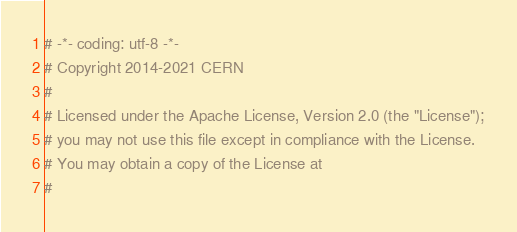Convert code to text. <code><loc_0><loc_0><loc_500><loc_500><_Python_># -*- coding: utf-8 -*-
# Copyright 2014-2021 CERN
#
# Licensed under the Apache License, Version 2.0 (the "License");
# you may not use this file except in compliance with the License.
# You may obtain a copy of the License at
#</code> 